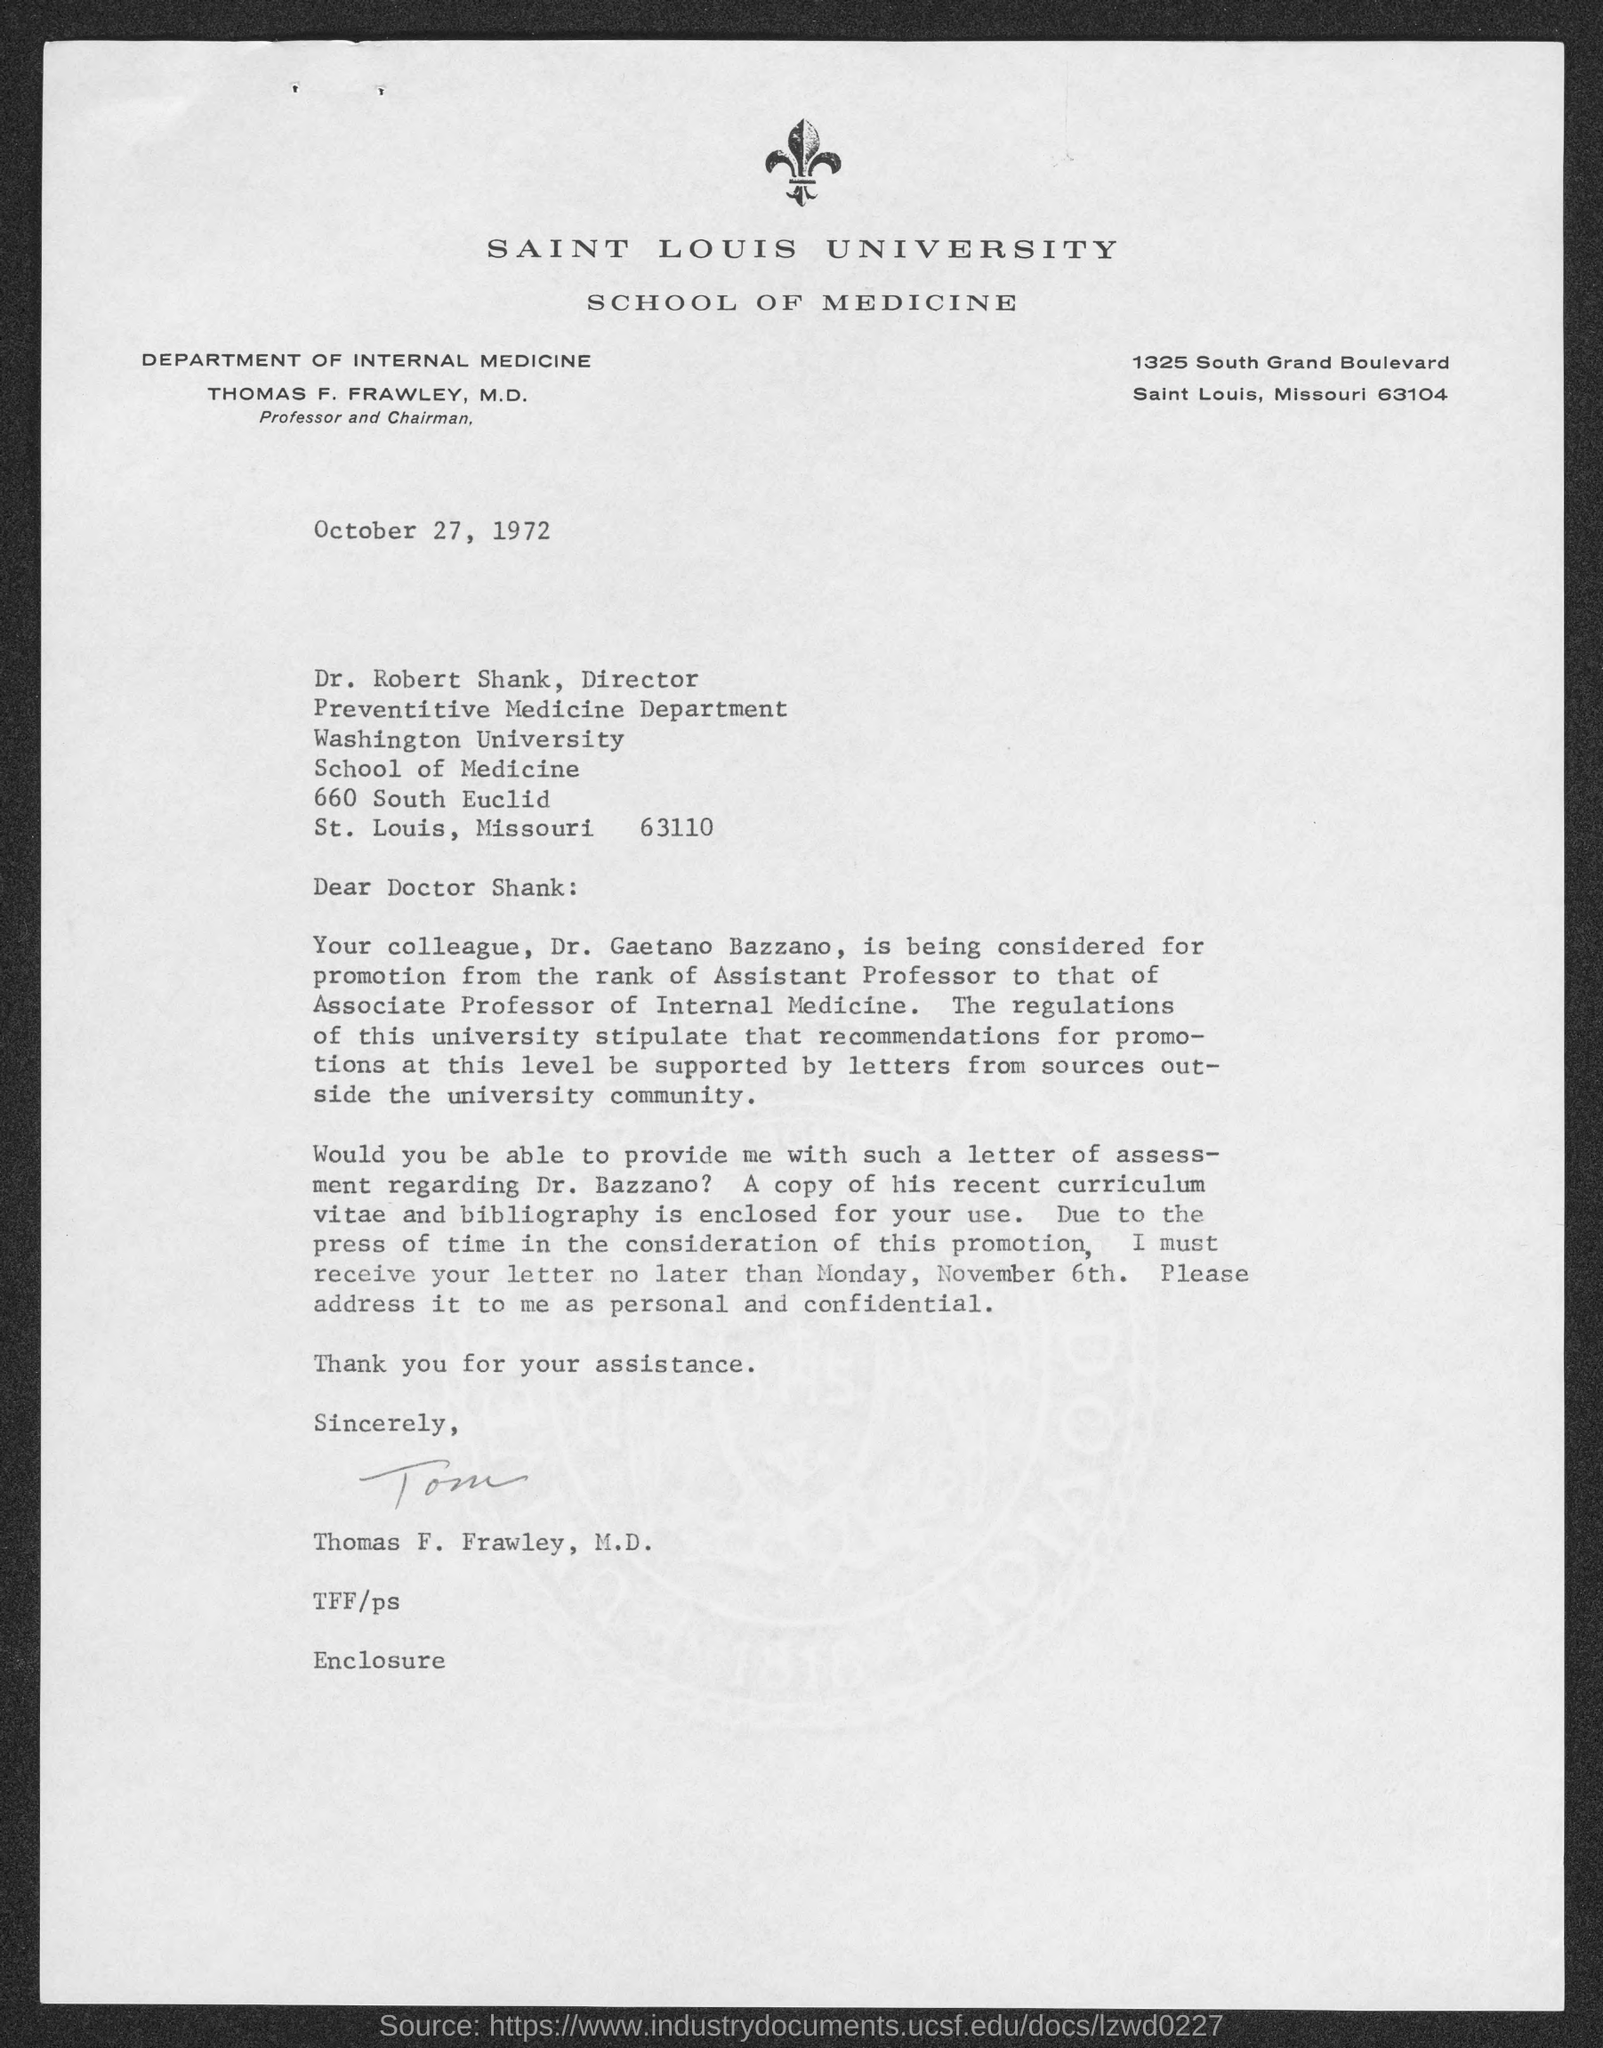Which University is mentioned in the letter head?
Keep it short and to the point. SAINT LOUIS UNIVERSITY. What is the designation of Thomas F. Frawley, M. D.?
Offer a very short reply. Professor and Chairman DEPARTMENT OF INTERNAL MEDICINE. Who is the sender of this letter?
Offer a terse response. Thomas F. Frawley, M. D. Who is the addressee of this letter?
Offer a terse response. Dr. Robert Shank. What is the deisgnation of Dr. Robert Shank?
Give a very brief answer. Director Preventive Medicine Department. 